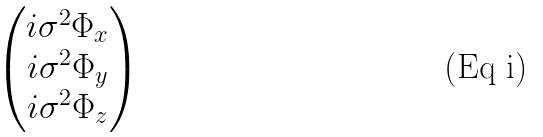Convert formula to latex. <formula><loc_0><loc_0><loc_500><loc_500>\begin{pmatrix} i \sigma ^ { 2 } \Phi _ { x } \\ i \sigma ^ { 2 } \Phi _ { y } \\ i \sigma ^ { 2 } \Phi _ { z } \end{pmatrix}</formula> 